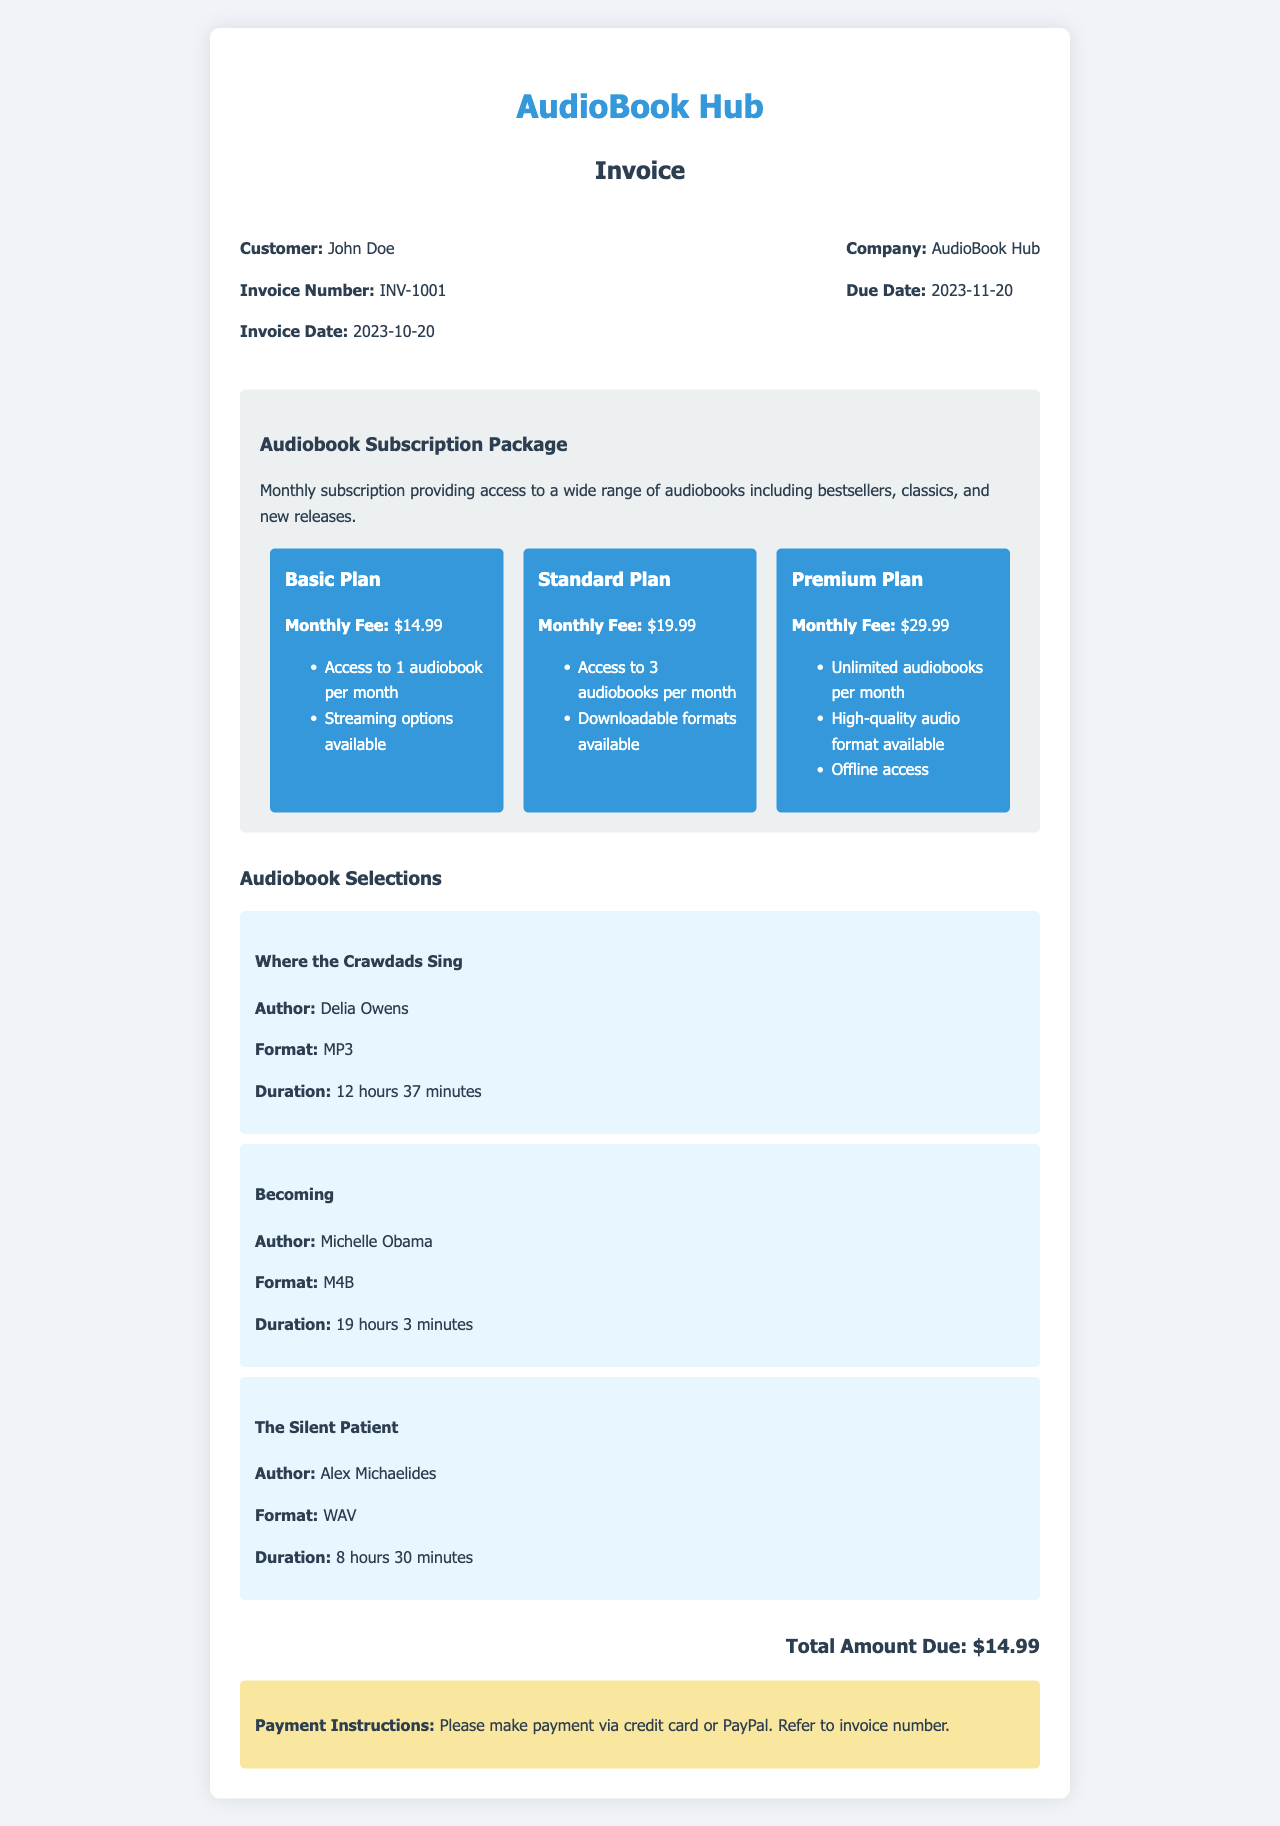What is the invoice number? The invoice number is clearly stated in the document under the invoice details section.
Answer: INV-1001 Who is the customer? The customer name is mentioned at the beginning of the document under the invoice details section.
Answer: John Doe What is the due date? The due date is specified in the invoice details and shows when the payment is expected.
Answer: 2023-11-20 What is the monthly fee for the Premium Plan? This fee is listed in the subscription plans section of the invoice.
Answer: $29.99 What audiobooks are in the selection? The audiobooks listed in the document detail the specific titles provided in the selections.
Answer: Where the Crawdads Sing, Becoming, The Silent Patient Which audio format is used for "Becoming"? The format is mentioned alongside the title in the audiobook selection details.
Answer: M4B How many audiobooks can be accessed under the Basic Plan? The number of audiobooks allowed is stated in the subscription plans section.
Answer: 1 audiobook What is the total amount due? This figure is calculated and displayed prominently at the end of the document.
Answer: $14.99 What are the payment options? The payment instructions specify how payment should be made, indicating the available options.
Answer: Credit card or PayPal 